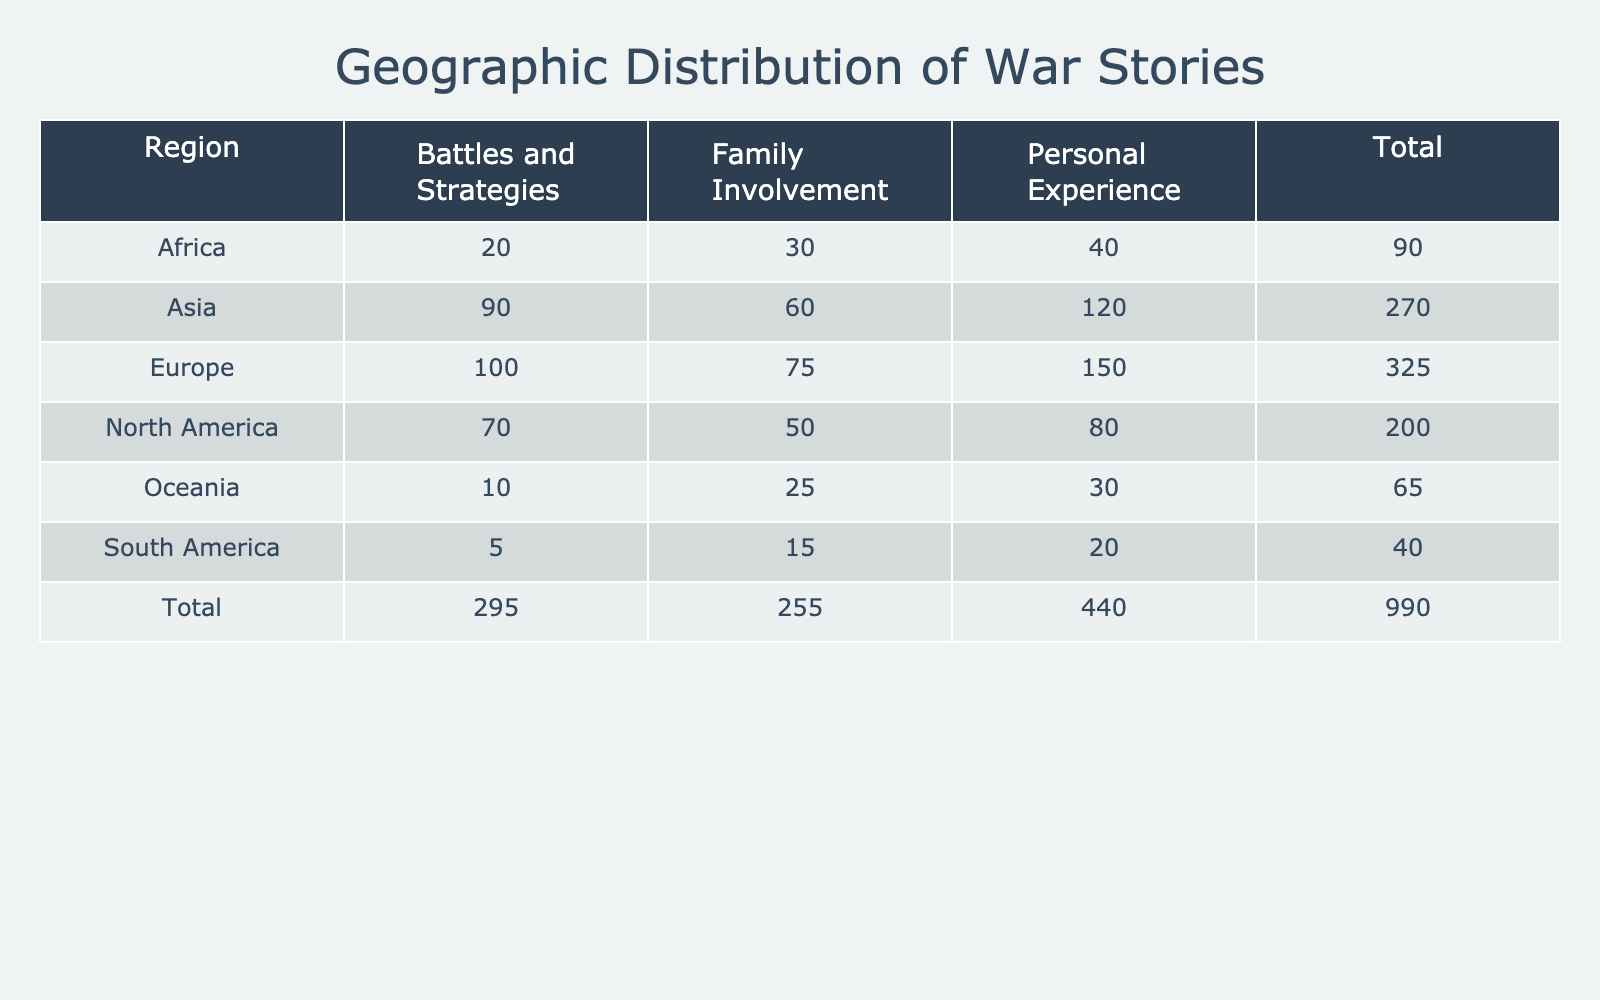What is the total number of personal experience stories collected from Europe? In the table, the number of personal experience stories from Europe is listed as 150. Therefore, the total number of personal experience stories collected from Europe is 150.
Answer: 150 Which region has the highest number of family involvement stories? The table shows that Europe has 75 family involvement stories, Asia has 60, North America has 50, Africa has 30, Oceania has 25, and South America has 15. Europe has the highest total at 75.
Answer: Europe How many more battles and strategies stories are there in Asia compared to Africa? The number of battles and strategies stories in Asia is 90, while in Africa it is 20. Thus, 90 - 20 = 70 indicates that there are 70 more battles and strategies stories in Asia than in Africa.
Answer: 70 What is the average number of stories across all types for North America? For North America, the numbers are: Personal Experience (80), Family Involvement (50), and Battles and Strategies (70). To find the average, we add 80 + 50 + 70 = 200, and divide by 3 (the number of types), which gives 200 / 3 = approximately 66.67.
Answer: 66.67 Is it true that South America has more personal experience stories than Oceania? South America has 20 personal experience stories and Oceania has 30. Since 20 is less than 30, the statement is false.
Answer: No Which region has the lowest total number of stories and what is that total? By examining the total stories for each region, we find: Europe = 325, Asia = 270, North America = 200, Africa = 90, Oceania = 65, and South America = 40. South America has the lowest total at 40.
Answer: South America, 40 What is the combined total of personal experience stories from Africa and Oceania? The personal experience stories from Africa are 40 and from Oceania are 30. Combining these gives 40 + 30 = 70.
Answer: 70 Which type of war story has the overall highest count across all regions? By combining the totals for each type: Personal Experience (150 + 120 + 80 + 40 + 30 + 20 = 440), Family Involvement (75 + 60 + 50 + 30 + 25 + 15 = 255), and Battles and Strategies (100 + 90 + 70 + 20 + 10 + 5 = 395). Personal Experience is the highest total at 440.
Answer: Personal Experience What is the difference between the total number of battles and strategies stories in Europe and South America? Europe has 100 battles and strategies stories and South America has 5. The difference is calculated as 100 - 5 = 95, meaning Europe has 95 more battles and strategies stories than South America.
Answer: 95 